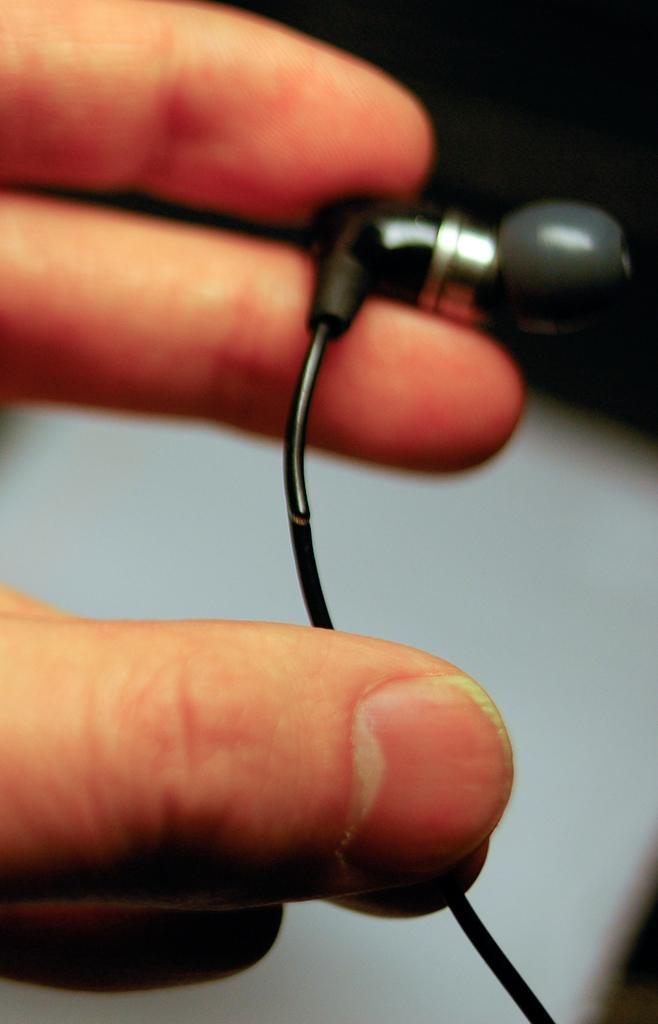Can you describe this image briefly? In the given image i can see a human hands holding ear phones. 